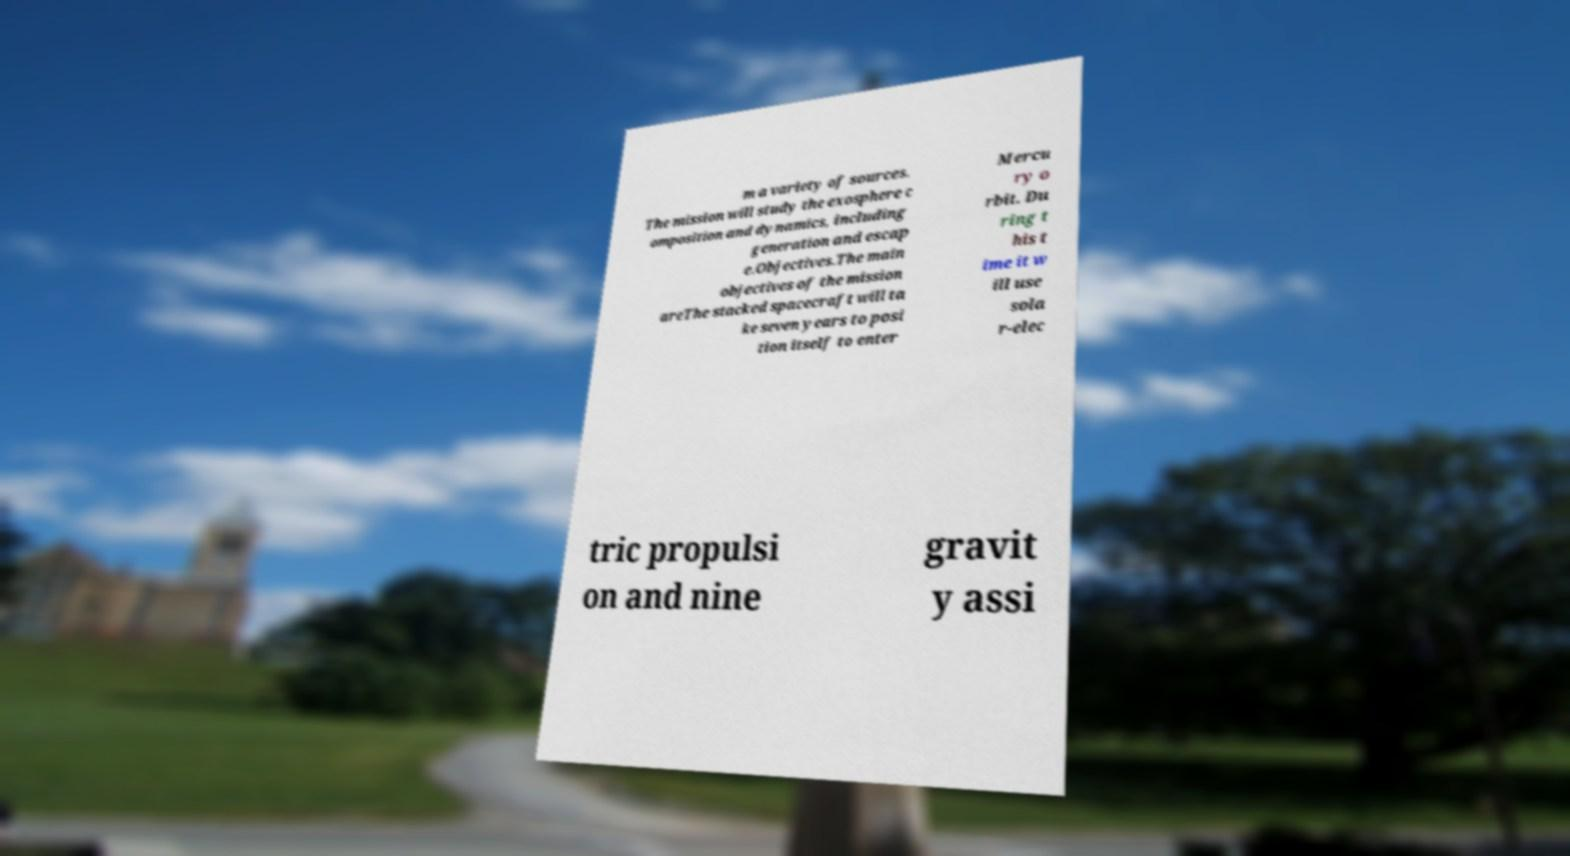Could you extract and type out the text from this image? m a variety of sources. The mission will study the exosphere c omposition and dynamics, including generation and escap e.Objectives.The main objectives of the mission areThe stacked spacecraft will ta ke seven years to posi tion itself to enter Mercu ry o rbit. Du ring t his t ime it w ill use sola r-elec tric propulsi on and nine gravit y assi 